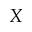Convert formula to latex. <formula><loc_0><loc_0><loc_500><loc_500>X</formula> 